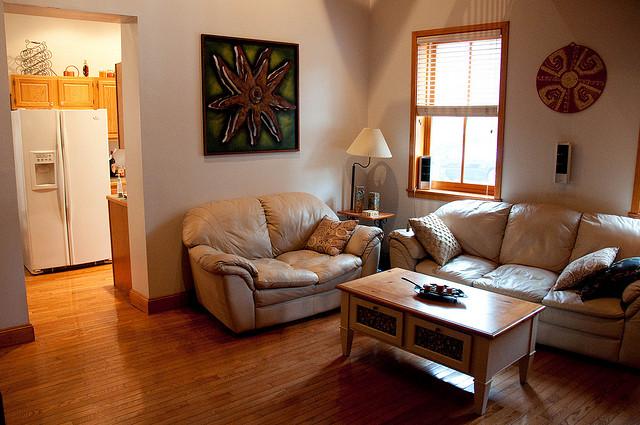Is this a hotel room?
Quick response, please. No. Is the sun coming through the window?
Concise answer only. Yes. What type of floor is this?
Short answer required. Wood. Are the blinds all the way up?
Be succinct. No. 